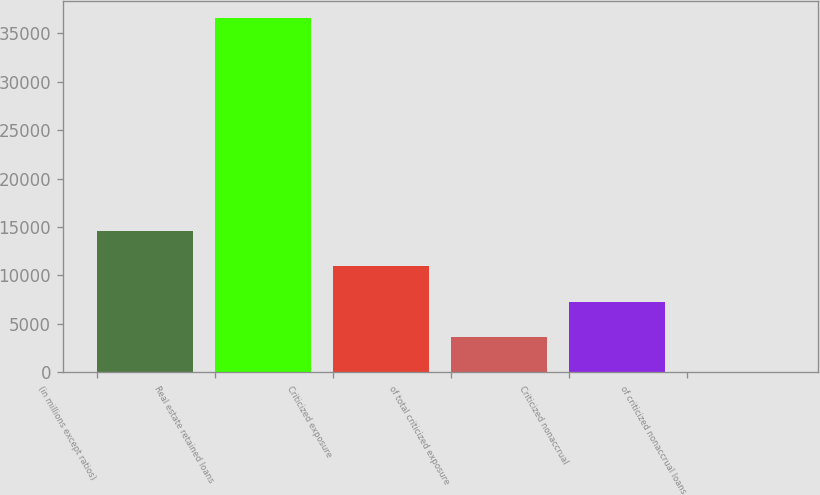Convert chart to OTSL. <chart><loc_0><loc_0><loc_500><loc_500><bar_chart><fcel>(in millions except ratios)<fcel>Real estate retained loans<fcel>Criticized exposure<fcel>of total criticized exposure<fcel>Criticized nonaccrual<fcel>of criticized nonaccrual loans<nl><fcel>14621.3<fcel>36553<fcel>10966<fcel>3655.49<fcel>7310.77<fcel>0.21<nl></chart> 